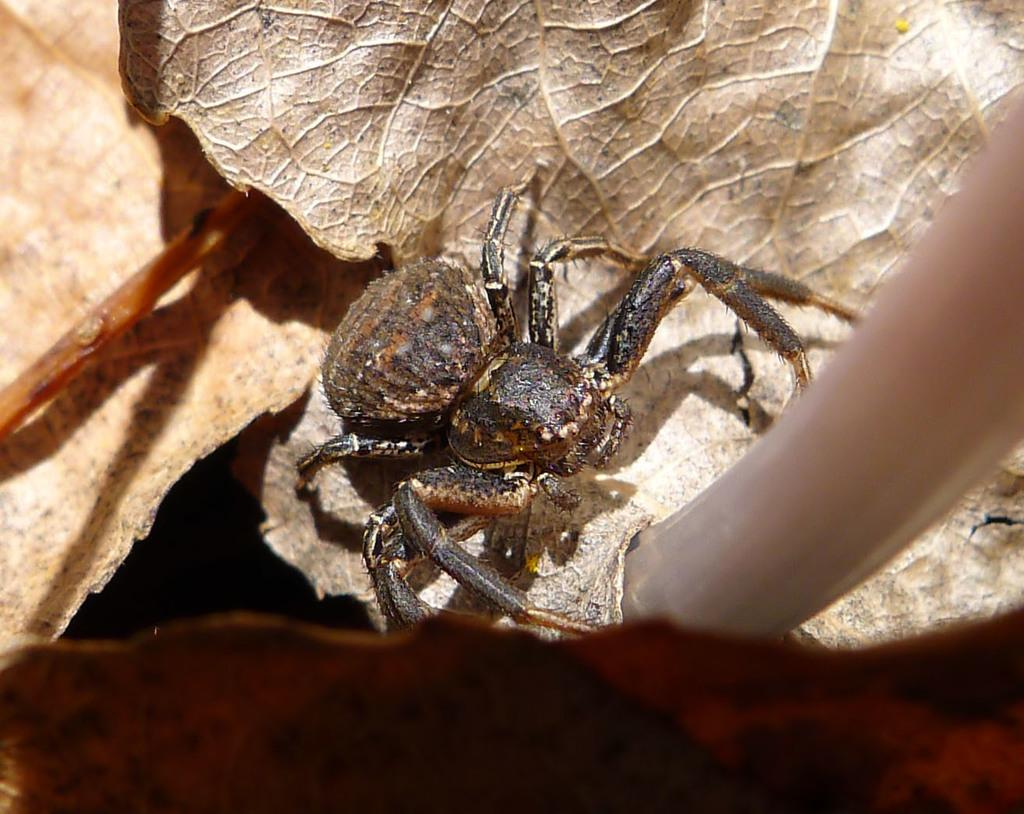What type of creature can be seen in the image? There is an insect in the image. Where is the insect located in relation to the dry leaves? The insect is present on dry leaves. Can you describe the position of the insect in the image? The insect is located in the center of the image. How many cats can be seen swimming in the lake in the image? There is no lake or cats present in the image; it features an insect on dry leaves. What type of fold is the insect using to navigate the image? The insect does not use a fold to navigate the image, as it is stationary on the dry leaves. 